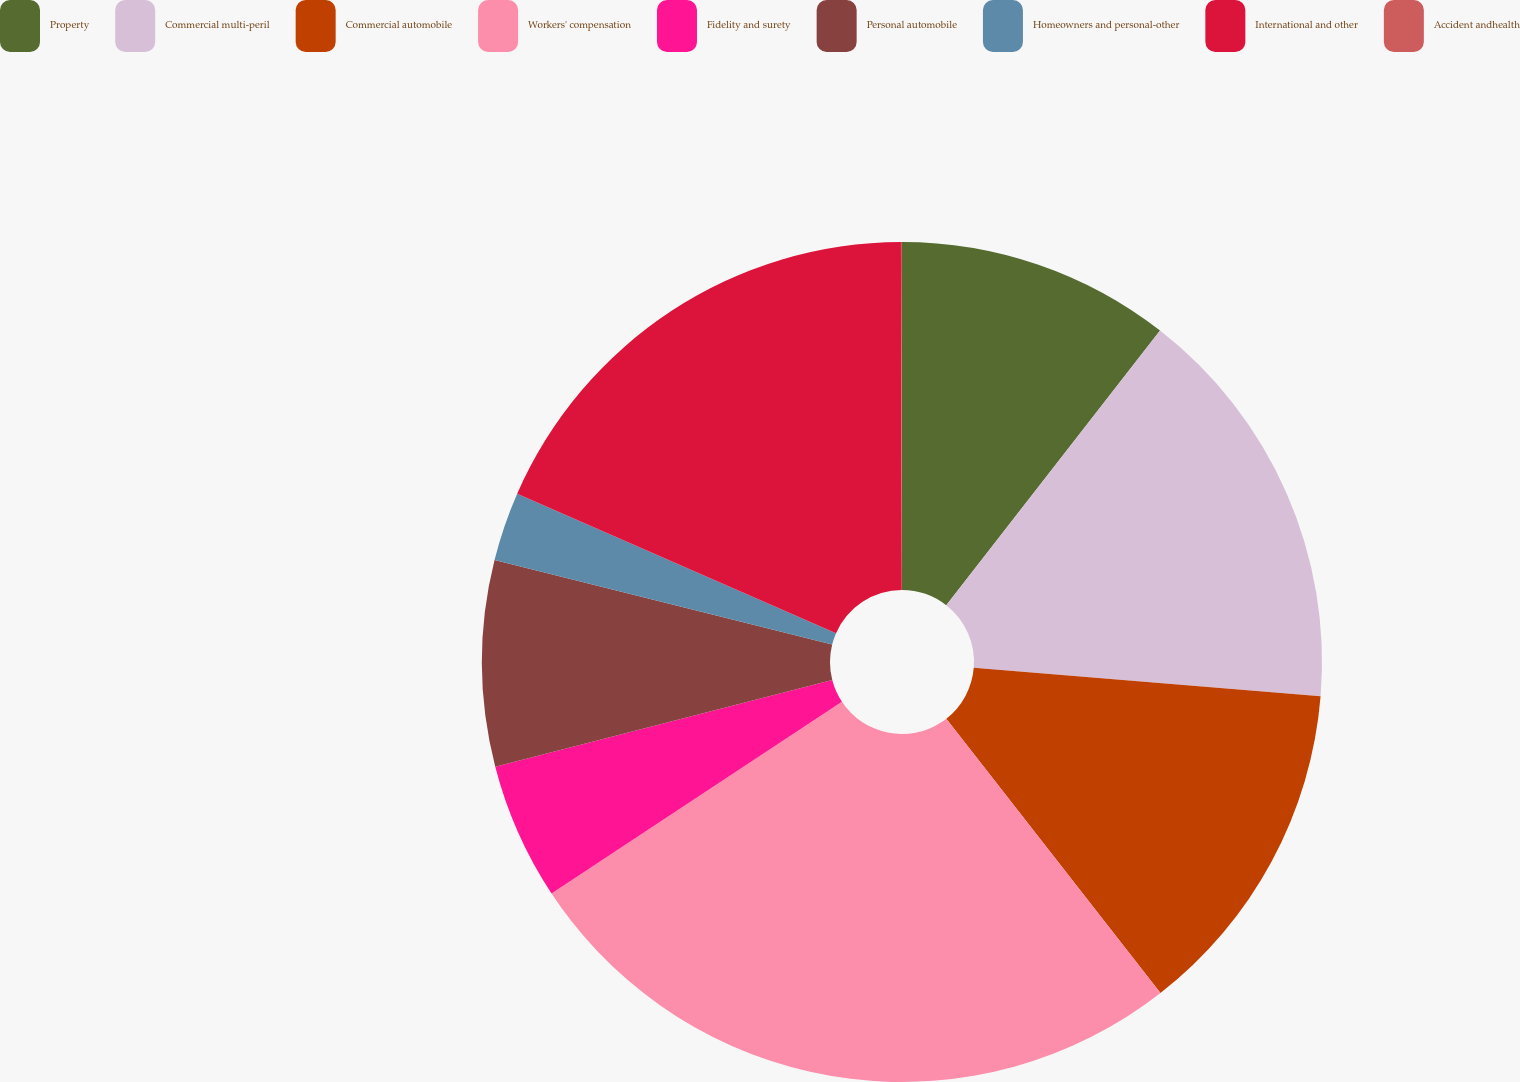<chart> <loc_0><loc_0><loc_500><loc_500><pie_chart><fcel>Property<fcel>Commercial multi-peril<fcel>Commercial automobile<fcel>Workers' compensation<fcel>Fidelity and surety<fcel>Personal automobile<fcel>Homeowners and personal-other<fcel>International and other<fcel>Accident andhealth<nl><fcel>10.53%<fcel>15.77%<fcel>13.15%<fcel>26.26%<fcel>5.28%<fcel>7.91%<fcel>2.66%<fcel>18.4%<fcel>0.04%<nl></chart> 